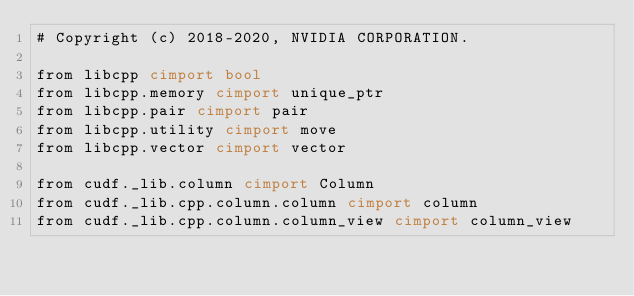Convert code to text. <code><loc_0><loc_0><loc_500><loc_500><_Cython_># Copyright (c) 2018-2020, NVIDIA CORPORATION.

from libcpp cimport bool
from libcpp.memory cimport unique_ptr
from libcpp.pair cimport pair
from libcpp.utility cimport move
from libcpp.vector cimport vector

from cudf._lib.column cimport Column
from cudf._lib.cpp.column.column cimport column
from cudf._lib.cpp.column.column_view cimport column_view</code> 